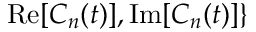Convert formula to latex. <formula><loc_0><loc_0><loc_500><loc_500>R e [ C _ { n } ( t ) ] , I m [ C _ { n } ( t ) ] \}</formula> 